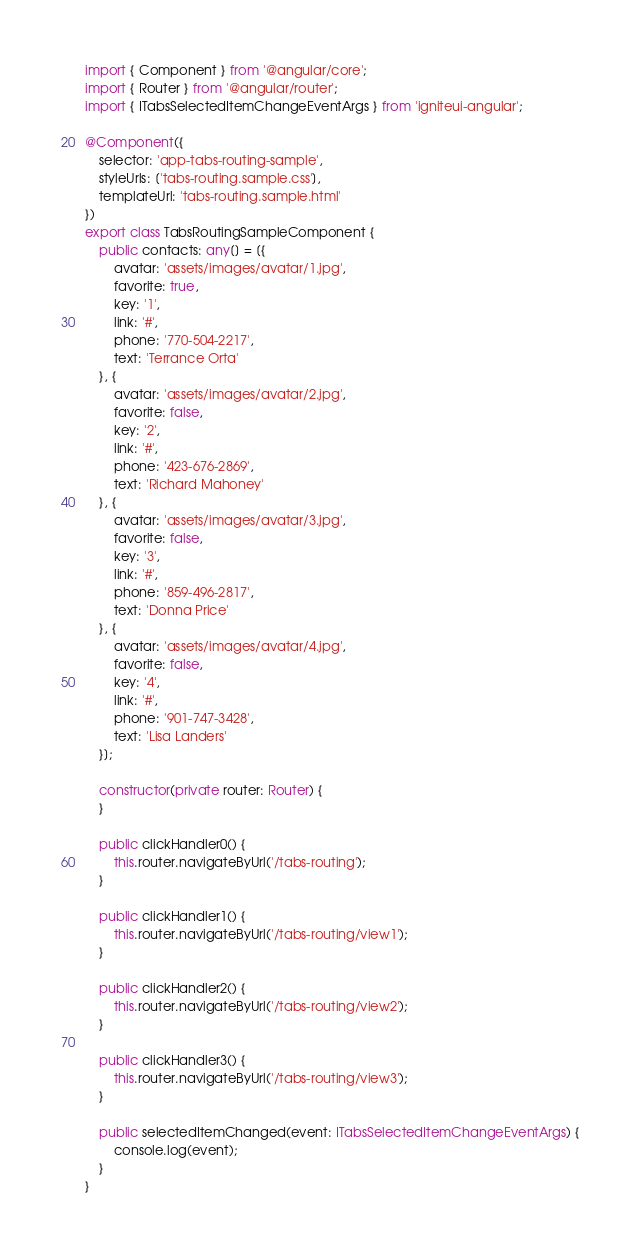<code> <loc_0><loc_0><loc_500><loc_500><_TypeScript_>import { Component } from '@angular/core';
import { Router } from '@angular/router';
import { ITabsSelectedItemChangeEventArgs } from 'igniteui-angular';

@Component({
    selector: 'app-tabs-routing-sample',
    styleUrls: ['tabs-routing.sample.css'],
    templateUrl: 'tabs-routing.sample.html'
})
export class TabsRoutingSampleComponent {
    public contacts: any[] = [{
        avatar: 'assets/images/avatar/1.jpg',
        favorite: true,
        key: '1',
        link: '#',
        phone: '770-504-2217',
        text: 'Terrance Orta'
    }, {
        avatar: 'assets/images/avatar/2.jpg',
        favorite: false,
        key: '2',
        link: '#',
        phone: '423-676-2869',
        text: 'Richard Mahoney'
    }, {
        avatar: 'assets/images/avatar/3.jpg',
        favorite: false,
        key: '3',
        link: '#',
        phone: '859-496-2817',
        text: 'Donna Price'
    }, {
        avatar: 'assets/images/avatar/4.jpg',
        favorite: false,
        key: '4',
        link: '#',
        phone: '901-747-3428',
        text: 'Lisa Landers'
    }];

    constructor(private router: Router) {
    }

    public clickHandler0() {
        this.router.navigateByUrl('/tabs-routing');
    }

    public clickHandler1() {
        this.router.navigateByUrl('/tabs-routing/view1');
    }

    public clickHandler2() {
        this.router.navigateByUrl('/tabs-routing/view2');
    }

    public clickHandler3() {
        this.router.navigateByUrl('/tabs-routing/view3');
    }

    public selectedItemChanged(event: ITabsSelectedItemChangeEventArgs) {
        console.log(event);
    }
}

</code> 